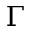Convert formula to latex. <formula><loc_0><loc_0><loc_500><loc_500>\Gamma</formula> 